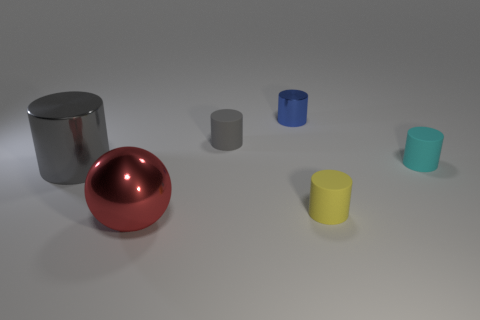Are the cyan thing and the tiny blue cylinder made of the same material?
Your answer should be very brief. No. What is the size of the matte cylinder that is the same color as the large metal cylinder?
Give a very brief answer. Small. Is there a object that has the same color as the large metal cylinder?
Give a very brief answer. Yes. What size is the gray thing that is made of the same material as the red thing?
Ensure brevity in your answer.  Large. There is a small thing behind the rubber cylinder that is left of the shiny object behind the large gray cylinder; what shape is it?
Offer a terse response. Cylinder. What is the size of the cyan thing that is the same shape as the blue thing?
Ensure brevity in your answer.  Small. What size is the metal thing that is both in front of the tiny gray cylinder and behind the red object?
Your response must be concise. Large. What shape is the small object that is the same color as the big cylinder?
Your response must be concise. Cylinder. The large ball is what color?
Your answer should be compact. Red. How big is the shiny cylinder in front of the tiny cyan matte object?
Offer a very short reply. Large. 